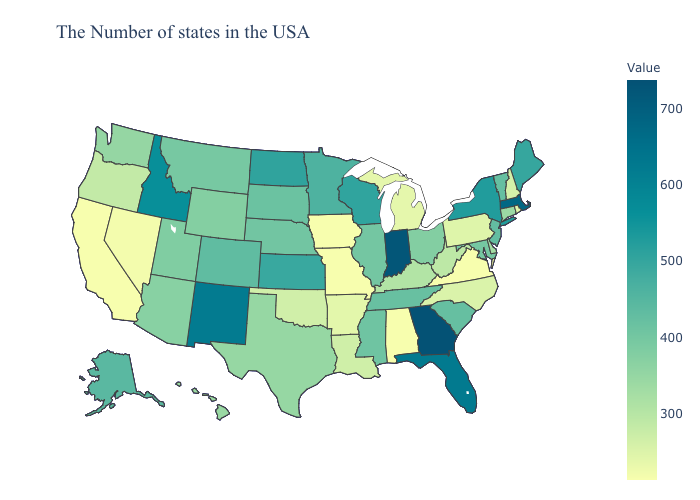Does Texas have the lowest value in the USA?
Keep it brief. No. Among the states that border North Carolina , which have the lowest value?
Give a very brief answer. Virginia. Which states have the lowest value in the Northeast?
Keep it brief. Rhode Island. Is the legend a continuous bar?
Short answer required. Yes. Which states have the highest value in the USA?
Keep it brief. Georgia. Does Nebraska have the lowest value in the MidWest?
Keep it brief. No. 